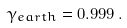Convert formula to latex. <formula><loc_0><loc_0><loc_500><loc_500>\gamma _ { e a r t h } = 0 . 9 9 9 \, .</formula> 